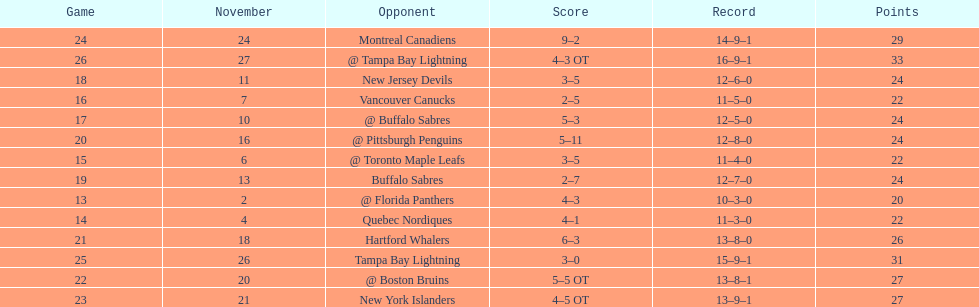The 1993-1994 flyers missed the playoffs again. how many consecutive seasons up until 93-94 did the flyers miss the playoffs? 5. 